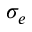Convert formula to latex. <formula><loc_0><loc_0><loc_500><loc_500>\sigma _ { e }</formula> 